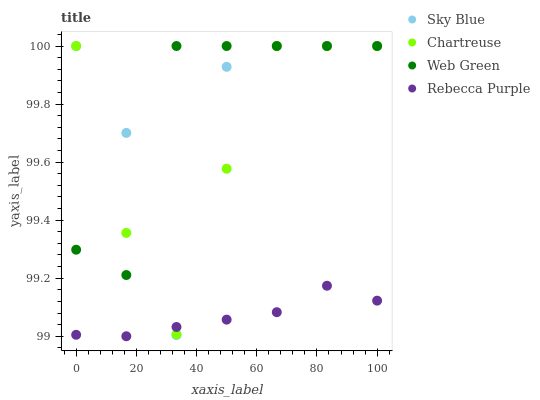Does Rebecca Purple have the minimum area under the curve?
Answer yes or no. Yes. Does Web Green have the maximum area under the curve?
Answer yes or no. Yes. Does Chartreuse have the minimum area under the curve?
Answer yes or no. No. Does Chartreuse have the maximum area under the curve?
Answer yes or no. No. Is Rebecca Purple the smoothest?
Answer yes or no. Yes. Is Sky Blue the roughest?
Answer yes or no. Yes. Is Chartreuse the smoothest?
Answer yes or no. No. Is Chartreuse the roughest?
Answer yes or no. No. Does Rebecca Purple have the lowest value?
Answer yes or no. Yes. Does Chartreuse have the lowest value?
Answer yes or no. No. Does Web Green have the highest value?
Answer yes or no. Yes. Does Rebecca Purple have the highest value?
Answer yes or no. No. Is Rebecca Purple less than Web Green?
Answer yes or no. Yes. Is Web Green greater than Rebecca Purple?
Answer yes or no. Yes. Does Rebecca Purple intersect Chartreuse?
Answer yes or no. Yes. Is Rebecca Purple less than Chartreuse?
Answer yes or no. No. Is Rebecca Purple greater than Chartreuse?
Answer yes or no. No. Does Rebecca Purple intersect Web Green?
Answer yes or no. No. 